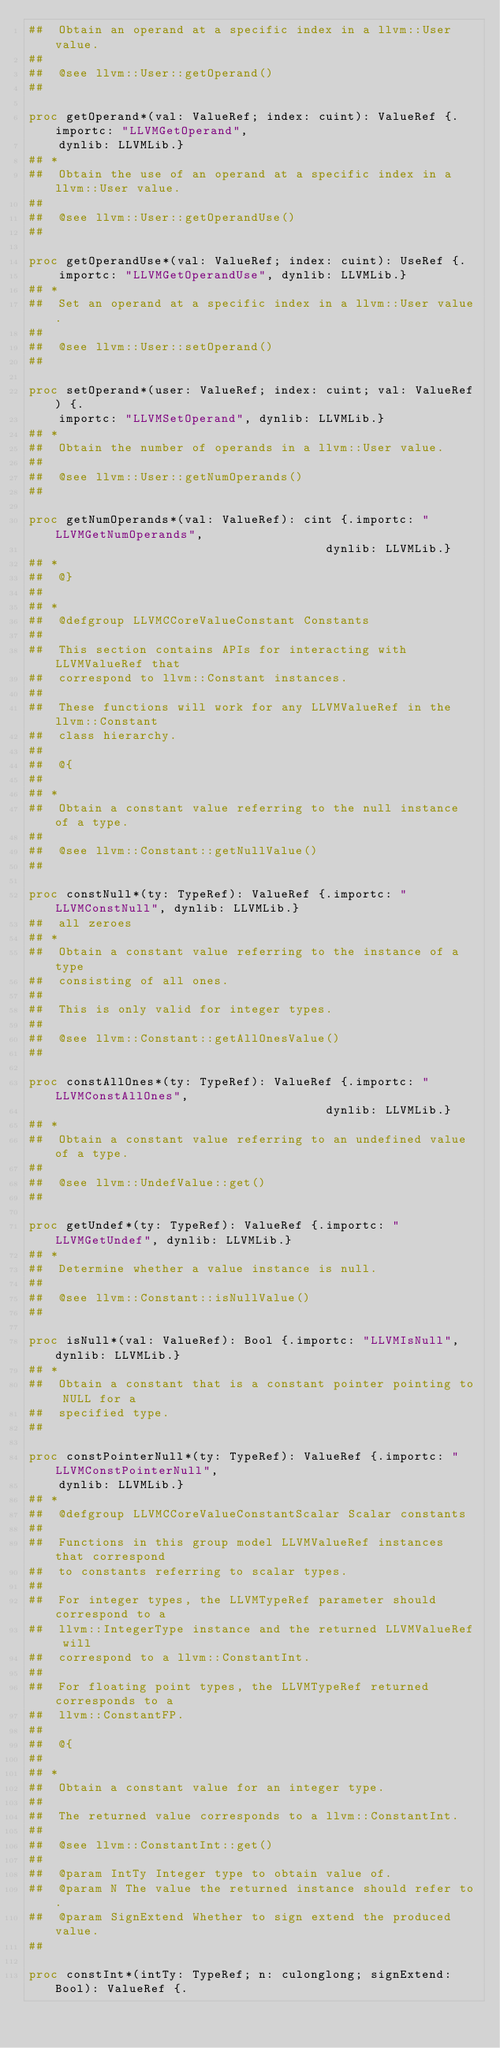Convert code to text. <code><loc_0><loc_0><loc_500><loc_500><_Nim_>##  Obtain an operand at a specific index in a llvm::User value.
##
##  @see llvm::User::getOperand()
##

proc getOperand*(val: ValueRef; index: cuint): ValueRef {.importc: "LLVMGetOperand",
    dynlib: LLVMLib.}
## *
##  Obtain the use of an operand at a specific index in a llvm::User value.
##
##  @see llvm::User::getOperandUse()
##

proc getOperandUse*(val: ValueRef; index: cuint): UseRef {.
    importc: "LLVMGetOperandUse", dynlib: LLVMLib.}
## *
##  Set an operand at a specific index in a llvm::User value.
##
##  @see llvm::User::setOperand()
##

proc setOperand*(user: ValueRef; index: cuint; val: ValueRef) {.
    importc: "LLVMSetOperand", dynlib: LLVMLib.}
## *
##  Obtain the number of operands in a llvm::User value.
##
##  @see llvm::User::getNumOperands()
##

proc getNumOperands*(val: ValueRef): cint {.importc: "LLVMGetNumOperands",
                                        dynlib: LLVMLib.}
## *
##  @}
##
## *
##  @defgroup LLVMCCoreValueConstant Constants
##
##  This section contains APIs for interacting with LLVMValueRef that
##  correspond to llvm::Constant instances.
##
##  These functions will work for any LLVMValueRef in the llvm::Constant
##  class hierarchy.
##
##  @{
##
## *
##  Obtain a constant value referring to the null instance of a type.
##
##  @see llvm::Constant::getNullValue()
##

proc constNull*(ty: TypeRef): ValueRef {.importc: "LLVMConstNull", dynlib: LLVMLib.}
##  all zeroes
## *
##  Obtain a constant value referring to the instance of a type
##  consisting of all ones.
##
##  This is only valid for integer types.
##
##  @see llvm::Constant::getAllOnesValue()
##

proc constAllOnes*(ty: TypeRef): ValueRef {.importc: "LLVMConstAllOnes",
                                        dynlib: LLVMLib.}
## *
##  Obtain a constant value referring to an undefined value of a type.
##
##  @see llvm::UndefValue::get()
##

proc getUndef*(ty: TypeRef): ValueRef {.importc: "LLVMGetUndef", dynlib: LLVMLib.}
## *
##  Determine whether a value instance is null.
##
##  @see llvm::Constant::isNullValue()
##

proc isNull*(val: ValueRef): Bool {.importc: "LLVMIsNull", dynlib: LLVMLib.}
## *
##  Obtain a constant that is a constant pointer pointing to NULL for a
##  specified type.
##

proc constPointerNull*(ty: TypeRef): ValueRef {.importc: "LLVMConstPointerNull",
    dynlib: LLVMLib.}
## *
##  @defgroup LLVMCCoreValueConstantScalar Scalar constants
##
##  Functions in this group model LLVMValueRef instances that correspond
##  to constants referring to scalar types.
##
##  For integer types, the LLVMTypeRef parameter should correspond to a
##  llvm::IntegerType instance and the returned LLVMValueRef will
##  correspond to a llvm::ConstantInt.
##
##  For floating point types, the LLVMTypeRef returned corresponds to a
##  llvm::ConstantFP.
##
##  @{
##
## *
##  Obtain a constant value for an integer type.
##
##  The returned value corresponds to a llvm::ConstantInt.
##
##  @see llvm::ConstantInt::get()
##
##  @param IntTy Integer type to obtain value of.
##  @param N The value the returned instance should refer to.
##  @param SignExtend Whether to sign extend the produced value.
##

proc constInt*(intTy: TypeRef; n: culonglong; signExtend: Bool): ValueRef {.</code> 